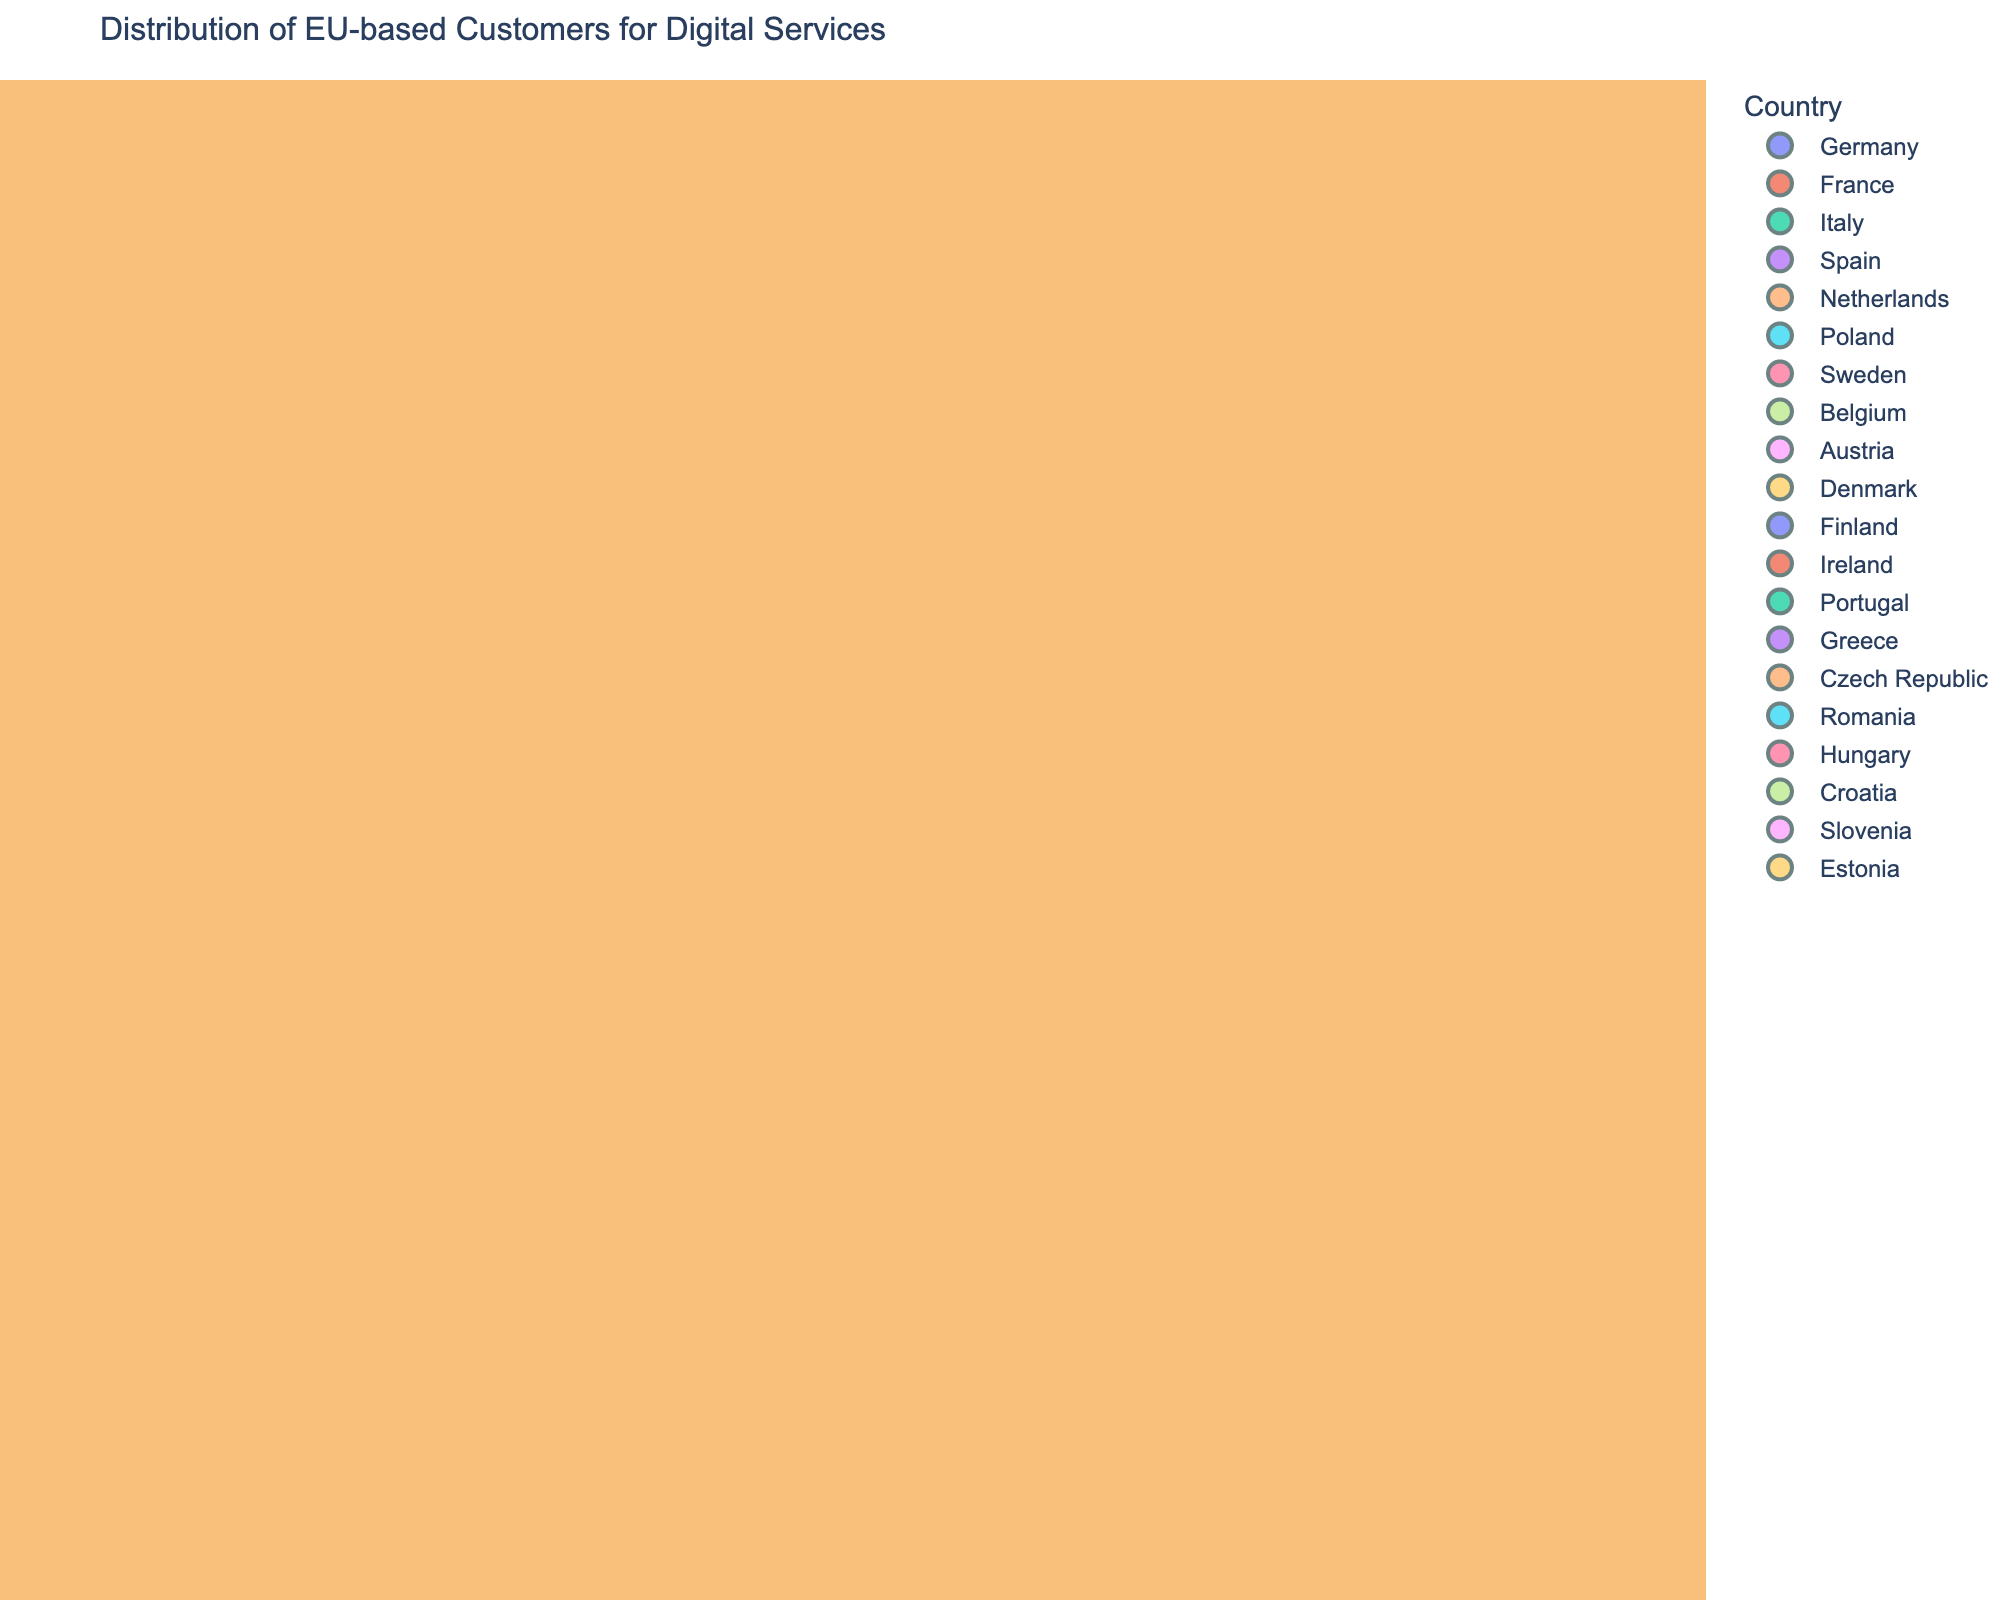what is the title of the 3D scatter plot? The title of the plot is usually displayed at the top of the figure and summarizes the overall content being shown. Look for the words at the topmost part of the plot.
Answer: Distribution of EU-based Customers for Digital Services Which country has the highest number of customers? Identify the largest data point in the plot, as size corresponds to the number of customers, and the hover name will show the country name.
Answer: Germany What is the range of ages represented in the figure? Observe the x-axis of the 3D scatter plot to determine the minimum and maximum values. These values represent the range of ages.
Answer: 22 to 50 Which country has the highest purchasing power, and what is the amount? Look for the data point that is at the highest y-coordinate, then identify the country and the corresponding purchasing power amount from the hover data.
Answer: Sweden, €50000 Among France and Italy, which country has more customers? Locate the points for France and Italy in the plot, then compare the sizes of the corresponding data points. The country with the larger data point has more customers.
Answer: France What is the purchasing power for a 30-year-old customer in Belgium? Find the data point corresponding to Belgium and look for the age of 30 on the x-axis. Check the y-axis value for purchasing power.
Answer: €44000 What country has customers with the lowest purchasing power, and what is the value? Identify the data point with the lowest y-coordinate on the y-axis and find the corresponding country and purchasing power.
Answer: Romania, €28000 Compare the number of customers in Poland and Denmark. Which country has more? Locate the data points for Poland and Denmark, then compare their sizes. The larger of the two indicates the country with more customers.
Answer: Poland 